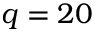Convert formula to latex. <formula><loc_0><loc_0><loc_500><loc_500>q = 2 0</formula> 